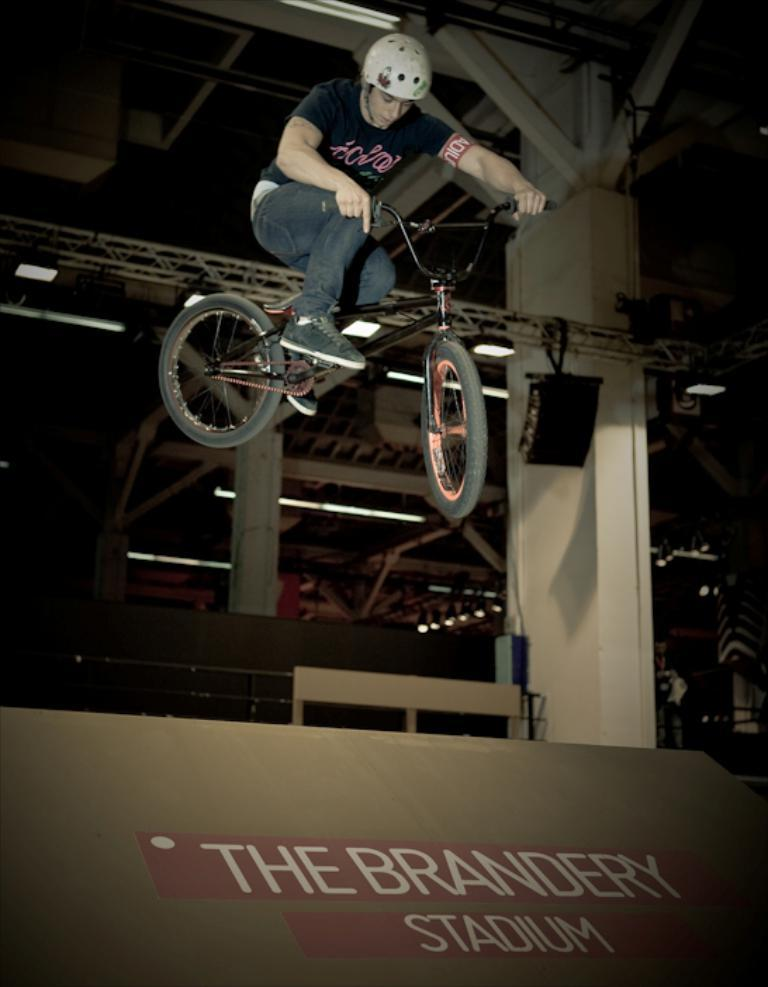What is the main subject of the image? There is a person in the image. What is the person doing in the image? The person is riding a bike. What other objects can be seen in the image? There are many lamps in the image. How many rabbits are sitting on the bike with the person in the image? There are no rabbits present in the image; it only features a person riding a bike and many lamps. 